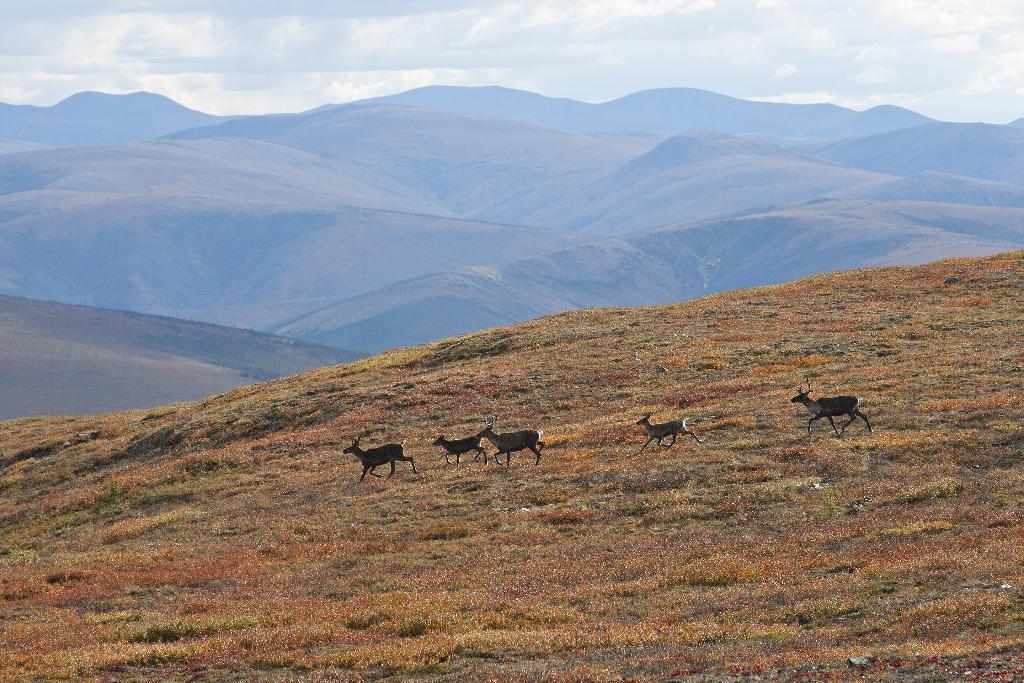Describe this image in one or two sentences. At the bottom of this image, there is grass on the ground. In the background, there are animals, mountains and there are clouds in the sky. 